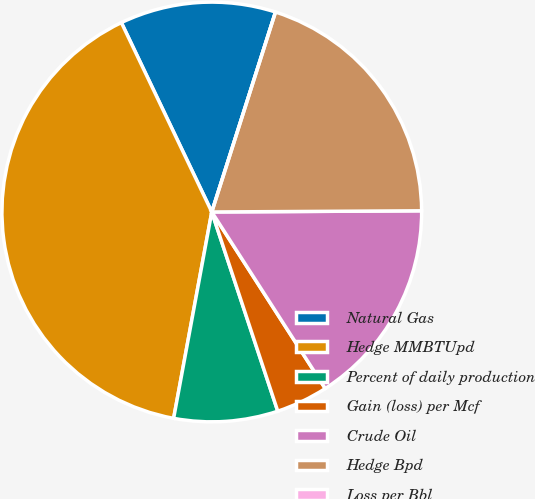Convert chart. <chart><loc_0><loc_0><loc_500><loc_500><pie_chart><fcel>Natural Gas<fcel>Hedge MMBTUpd<fcel>Percent of daily production<fcel>Gain (loss) per Mcf<fcel>Crude Oil<fcel>Hedge Bpd<fcel>Loss per Bbl<nl><fcel>12.0%<fcel>40.0%<fcel>8.0%<fcel>4.0%<fcel>16.0%<fcel>20.0%<fcel>0.0%<nl></chart> 